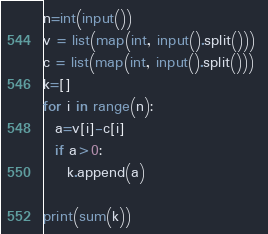<code> <loc_0><loc_0><loc_500><loc_500><_Python_>n=int(input())
v = list(map(int, input().split())) 
c = list(map(int, input().split())) 
k=[]
for i in range(n):
  a=v[i]-c[i]
  if a>0:
    k.append(a)

print(sum(k))</code> 